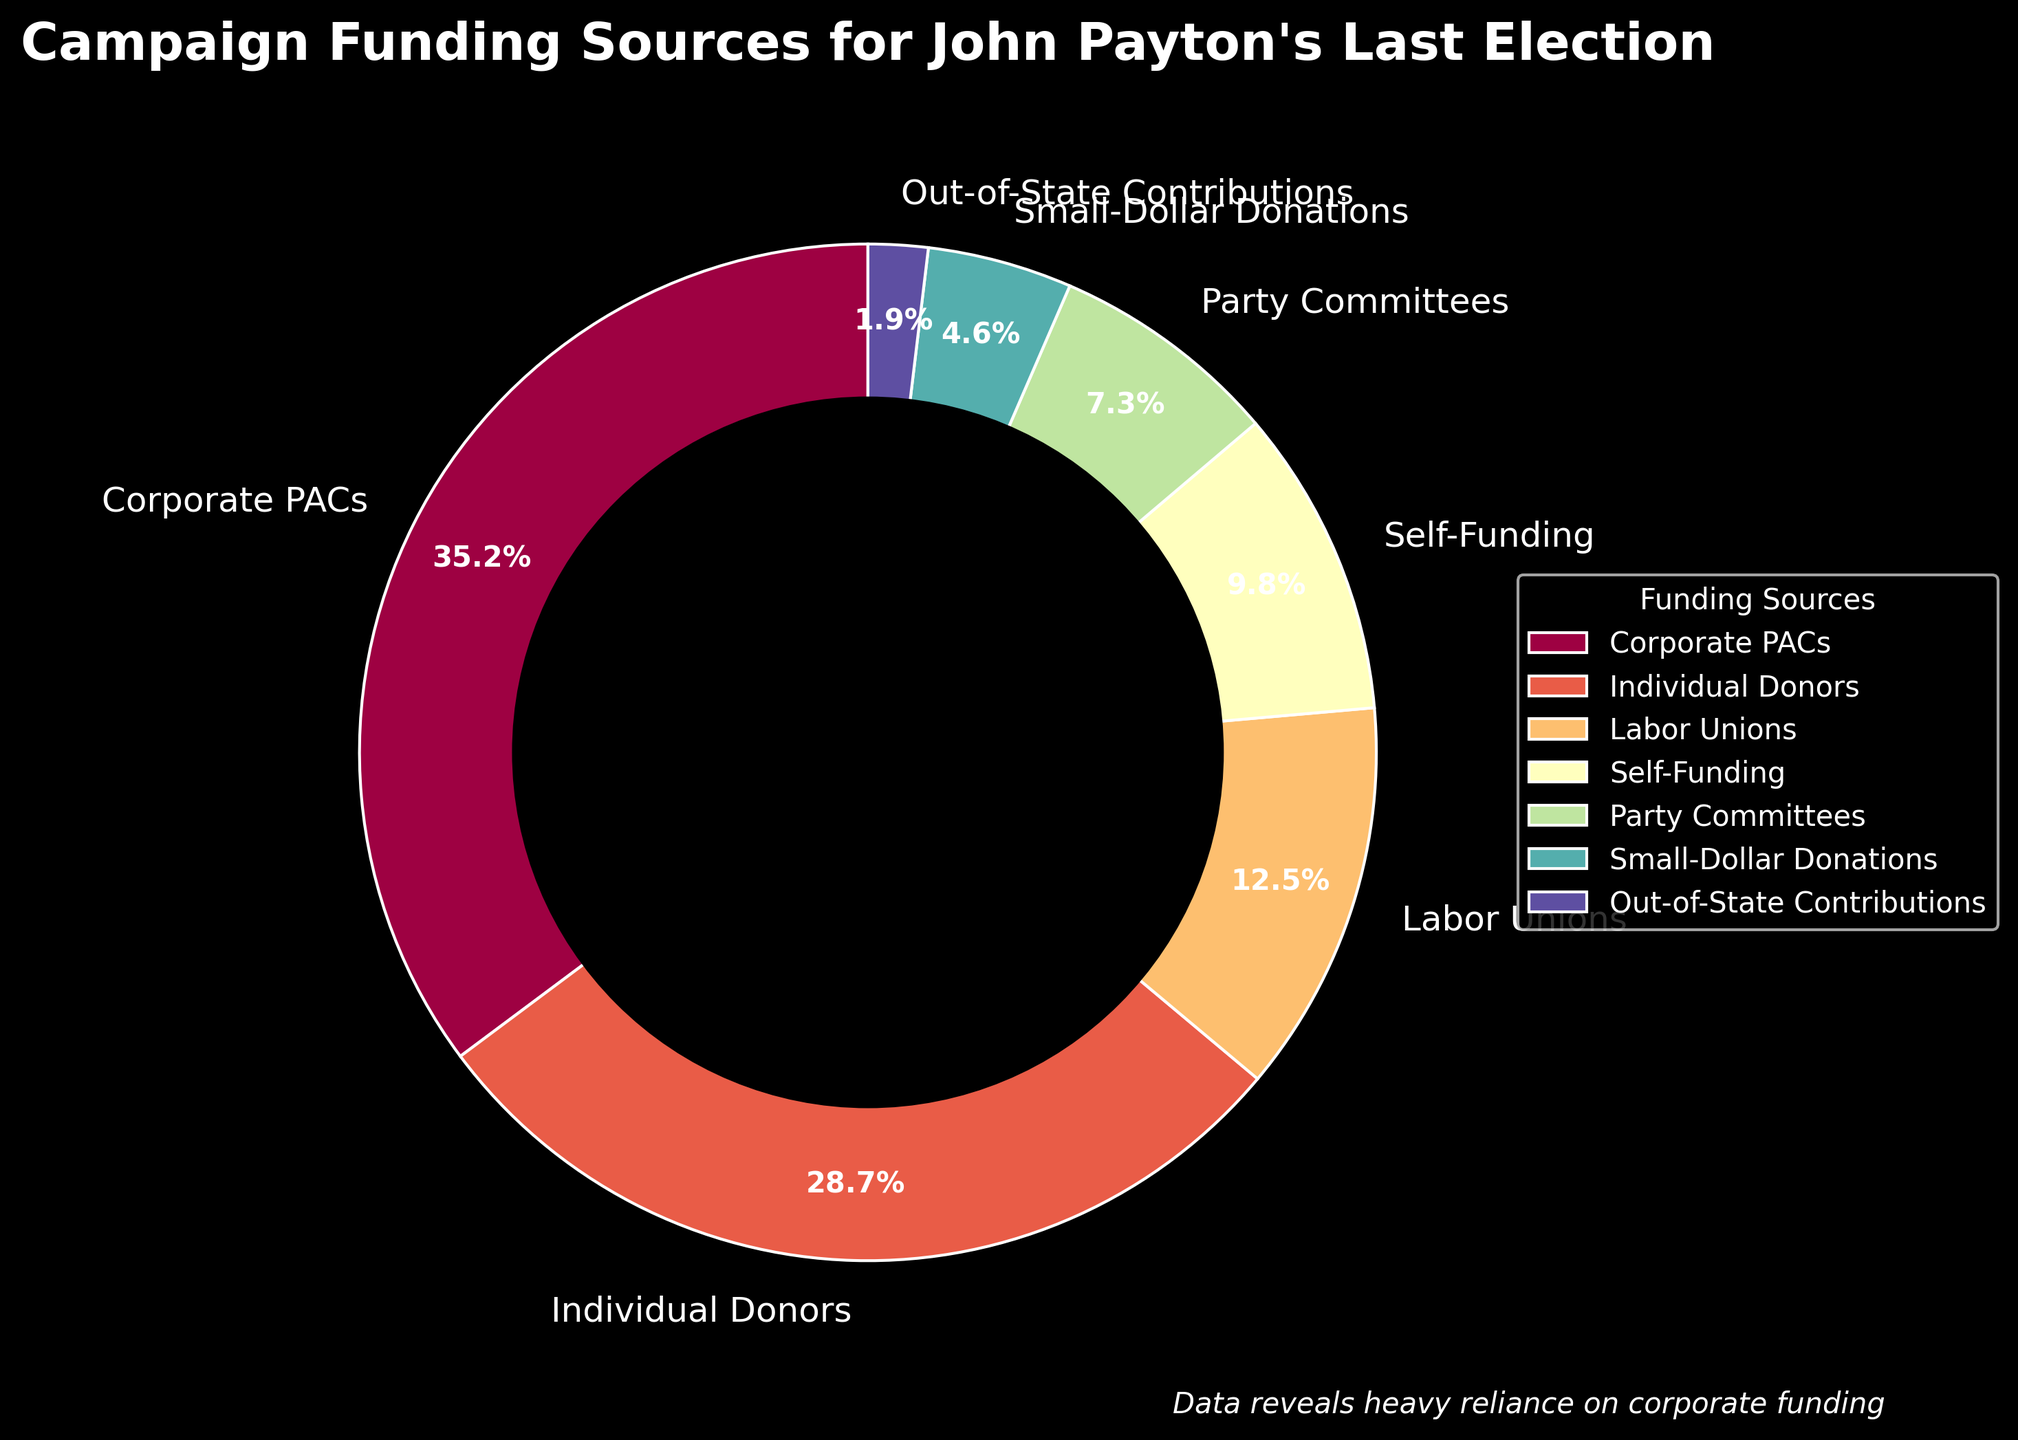What percentage of John Payton's campaign funding came from Corporate PACs? The segment labeled "Corporate PACs" on the pie chart indicates the percentage.
Answer: 35.2% What percentage of campaign funding came from both Party Committees and Labor Unions combined? Sum the percentages for Party Committees (7.3%) and Labor Unions (12.5%). (7.3 + 12.5) = 19.8%
Answer: 19.8% Which funding source contributed the least to John Payton's campaign? Identify the smallest segment in the pie chart, which is labeled "Out-of-State Contributions".
Answer: Out-of-State Contributions How does the percentage of Individual Donors compare to Small-Dollar Donations? Compare the segments labeled "Individual Donors" (28.7%) and "Small-Dollar Donations" (4.6%). 28.7% is significantly larger.
Answer: Individual Donors contributed more What is the combined contribution of Self-Funding and Small-Dollar Donations? Sum the percentages for Self-Funding (9.8%) and Small-Dollar Donations (4.6%). (9.8 + 4.6) = 14.4%
Answer: 14.4% What portion of the campaign funding came from sources other than Corporate PACs and Individual Donors? Sum all percentages excluding Corporate PACs (35.2%) and Individual Donors (28.7%). (100 - 35.2 - 28.7) = 36.1%
Answer: 36.1% Which source had the second highest level of funding? The second largest segment is labeled "Individual Donors" with 28.7%.
Answer: Individual Donors If John Payton's campign received an additional 2% from Out-of-State Contributions, what would be the new percentage for this category? Add 2% to the original percentage for Out-of-State Contributions (1.9%). (1.9 + 2) = 3.9%
Answer: 3.9% How much greater is Corporate PACs' contribution compared to Labor Unions'? Subtract the Labor Unions' contribution (12.5%) from Corporate PACs' contribution (35.2%). (35.2 - 12.5) = 22.7%
Answer: 22.7% 